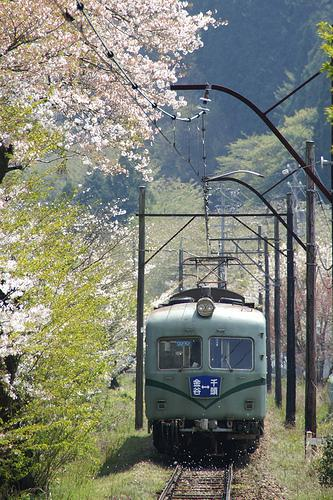Question: what is the main focus of the picture?
Choices:
A. The car.
B. The tree.
C. The train.
D. The bushes.
Answer with the letter. Answer: C Question: what takes up the left side of the picture?
Choices:
A. Flowers.
B. Bushes.
C. Weeds.
D. Trees.
Answer with the letter. Answer: A Question: where is this taken?
Choices:
A. Parking garage.
B. Train tracks.
C. Parking lot.
D. A store.
Answer with the letter. Answer: B 